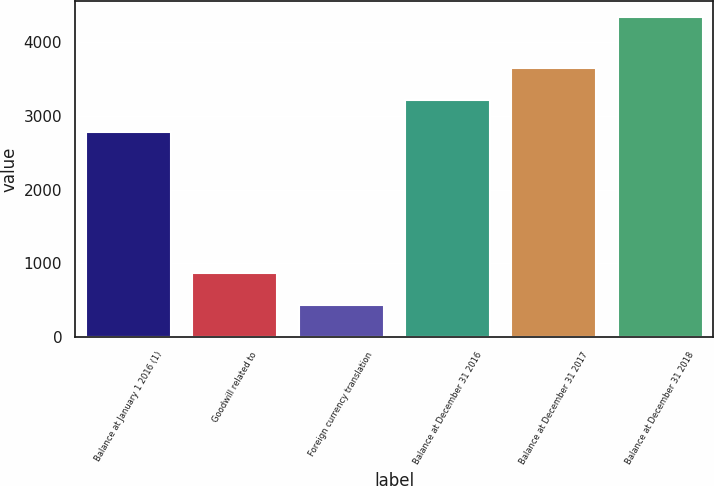<chart> <loc_0><loc_0><loc_500><loc_500><bar_chart><fcel>Balance at January 1 2016 (1)<fcel>Goodwill related to<fcel>Foreign currency translation<fcel>Balance at December 31 2016<fcel>Balance at December 31 2017<fcel>Balance at December 31 2018<nl><fcel>2786<fcel>872.4<fcel>438.7<fcel>3219.7<fcel>3653.4<fcel>4342<nl></chart> 